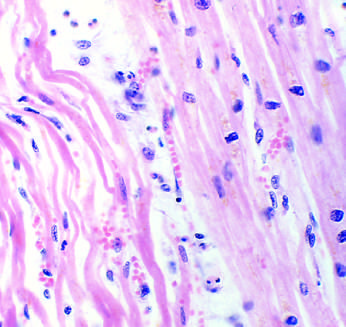what are necrotic cells separated by?
Answer the question using a single word or phrase. Edema fluid 